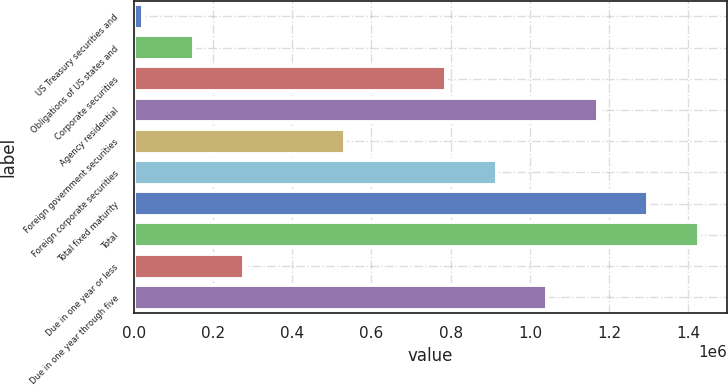<chart> <loc_0><loc_0><loc_500><loc_500><bar_chart><fcel>US Treasury securities and<fcel>Obligations of US states and<fcel>Corporate securities<fcel>Agency residential<fcel>Foreign government securities<fcel>Foreign corporate securities<fcel>Total fixed maturity<fcel>Total<fcel>Due in one year or less<fcel>Due in one year through five<nl><fcel>24854<fcel>152196<fcel>788907<fcel>1.17093e+06<fcel>534222<fcel>916249<fcel>1.29828e+06<fcel>1.42562e+06<fcel>279538<fcel>1.04359e+06<nl></chart> 